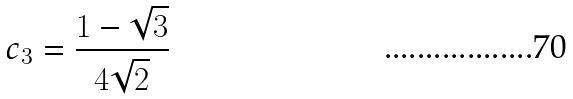<formula> <loc_0><loc_0><loc_500><loc_500>c _ { 3 } = \frac { 1 - \sqrt { 3 } } { 4 \sqrt { 2 } }</formula> 